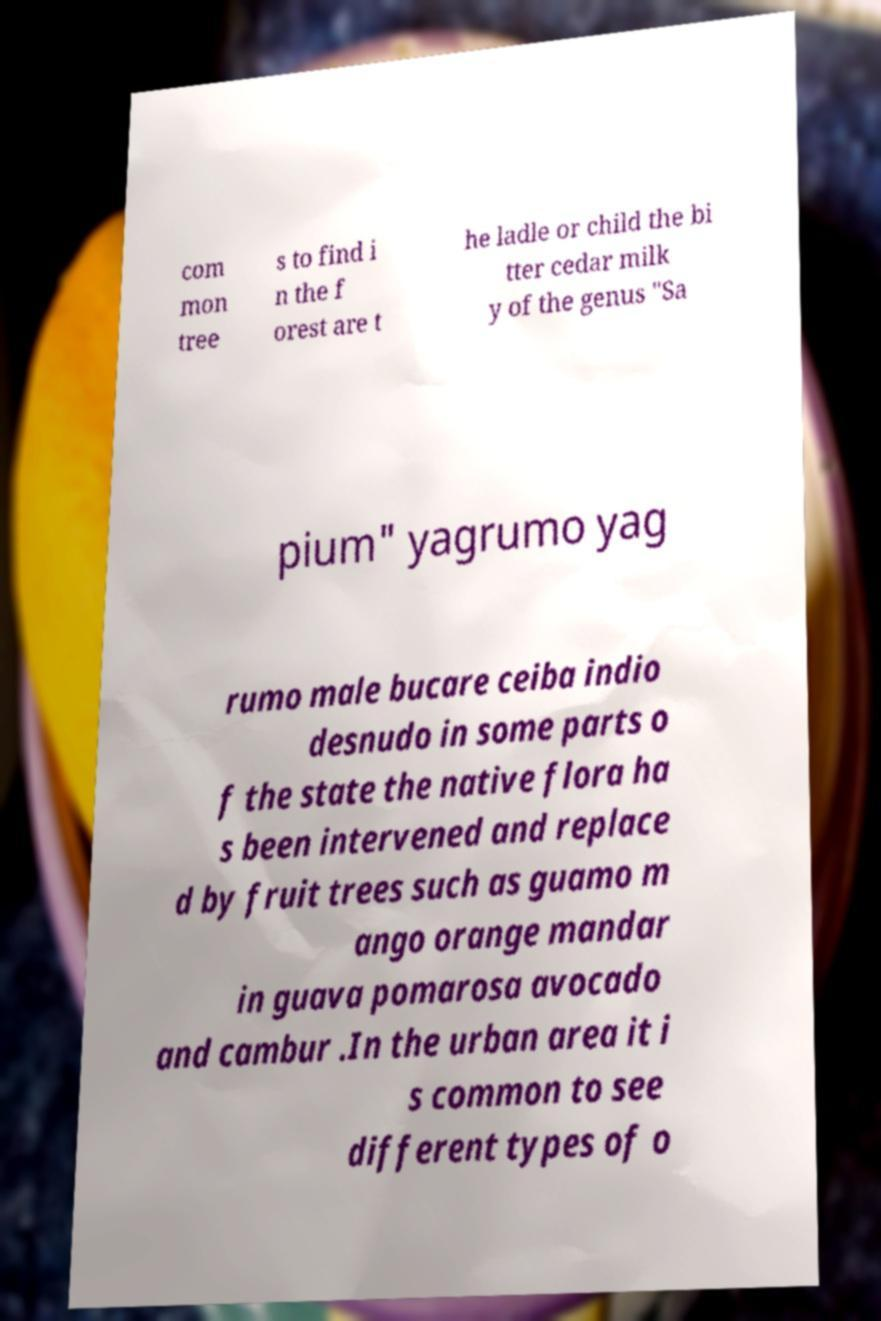Could you extract and type out the text from this image? com mon tree s to find i n the f orest are t he ladle or child the bi tter cedar milk y of the genus "Sa pium" yagrumo yag rumo male bucare ceiba indio desnudo in some parts o f the state the native flora ha s been intervened and replace d by fruit trees such as guamo m ango orange mandar in guava pomarosa avocado and cambur .In the urban area it i s common to see different types of o 